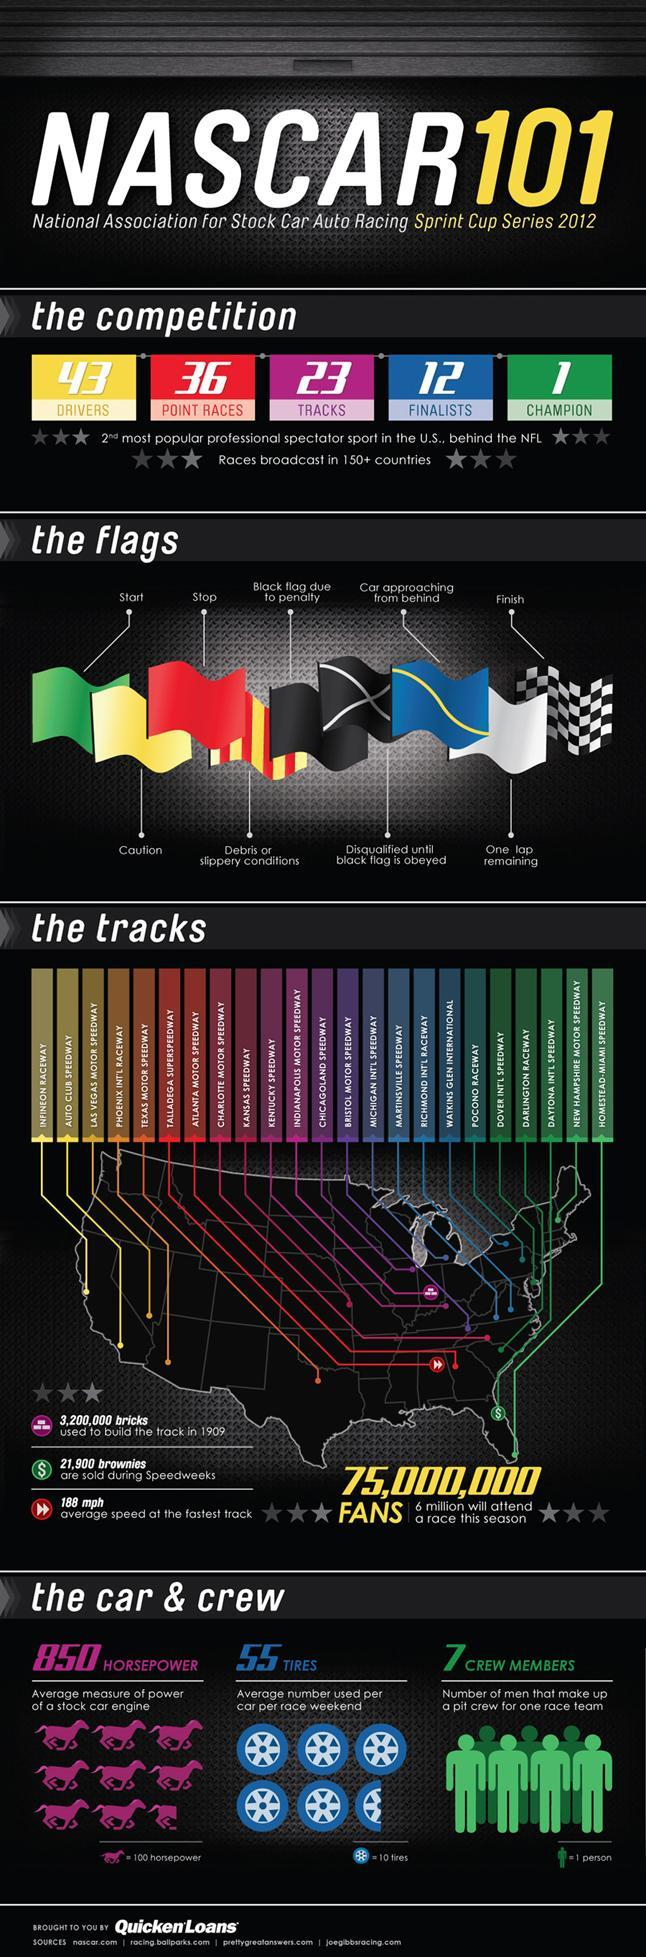How many point races?
Answer the question with a short phrase. 36 How many finalists? 12 How many flags used in the Championship? 9 Which is the most popular professional spectator sport in the U.S? NFL 